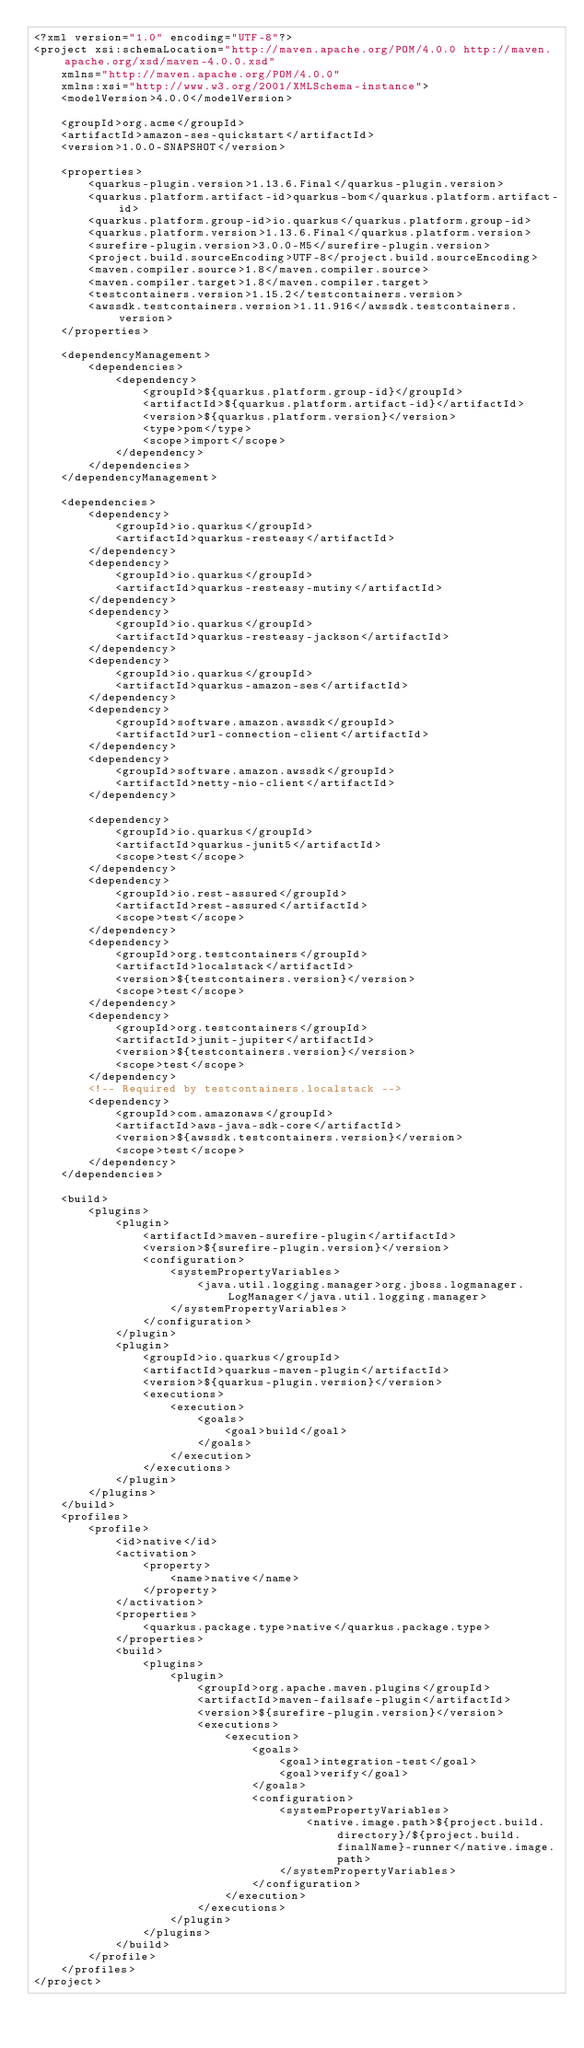Convert code to text. <code><loc_0><loc_0><loc_500><loc_500><_XML_><?xml version="1.0" encoding="UTF-8"?>
<project xsi:schemaLocation="http://maven.apache.org/POM/4.0.0 http://maven.apache.org/xsd/maven-4.0.0.xsd" 
    xmlns="http://maven.apache.org/POM/4.0.0" 
    xmlns:xsi="http://www.w3.org/2001/XMLSchema-instance">
    <modelVersion>4.0.0</modelVersion>

    <groupId>org.acme</groupId>
    <artifactId>amazon-ses-quickstart</artifactId>
    <version>1.0.0-SNAPSHOT</version>

    <properties>
        <quarkus-plugin.version>1.13.6.Final</quarkus-plugin.version>
        <quarkus.platform.artifact-id>quarkus-bom</quarkus.platform.artifact-id>
        <quarkus.platform.group-id>io.quarkus</quarkus.platform.group-id>
        <quarkus.platform.version>1.13.6.Final</quarkus.platform.version>
        <surefire-plugin.version>3.0.0-M5</surefire-plugin.version>
        <project.build.sourceEncoding>UTF-8</project.build.sourceEncoding>
        <maven.compiler.source>1.8</maven.compiler.source>
        <maven.compiler.target>1.8</maven.compiler.target>
        <testcontainers.version>1.15.2</testcontainers.version>
        <awssdk.testcontainers.version>1.11.916</awssdk.testcontainers.version>
    </properties>

    <dependencyManagement>
        <dependencies>
            <dependency>
                <groupId>${quarkus.platform.group-id}</groupId>
                <artifactId>${quarkus.platform.artifact-id}</artifactId>
                <version>${quarkus.platform.version}</version>
                <type>pom</type>
                <scope>import</scope>
            </dependency>
        </dependencies>
    </dependencyManagement>

    <dependencies>
        <dependency>
            <groupId>io.quarkus</groupId>
            <artifactId>quarkus-resteasy</artifactId>
        </dependency>
        <dependency>
            <groupId>io.quarkus</groupId>
            <artifactId>quarkus-resteasy-mutiny</artifactId>
        </dependency>
        <dependency>
            <groupId>io.quarkus</groupId>
            <artifactId>quarkus-resteasy-jackson</artifactId>
        </dependency>
        <dependency>
            <groupId>io.quarkus</groupId>
            <artifactId>quarkus-amazon-ses</artifactId>
        </dependency>
        <dependency>
            <groupId>software.amazon.awssdk</groupId>
            <artifactId>url-connection-client</artifactId>
        </dependency>
        <dependency>
            <groupId>software.amazon.awssdk</groupId>
            <artifactId>netty-nio-client</artifactId>
        </dependency>

        <dependency>
            <groupId>io.quarkus</groupId>
            <artifactId>quarkus-junit5</artifactId>
            <scope>test</scope>
        </dependency>
        <dependency>
            <groupId>io.rest-assured</groupId>
            <artifactId>rest-assured</artifactId>
            <scope>test</scope>
        </dependency>
        <dependency>
            <groupId>org.testcontainers</groupId>
            <artifactId>localstack</artifactId>
            <version>${testcontainers.version}</version>
            <scope>test</scope>
        </dependency>
        <dependency>
            <groupId>org.testcontainers</groupId>
            <artifactId>junit-jupiter</artifactId>
            <version>${testcontainers.version}</version>
            <scope>test</scope>
        </dependency>
        <!-- Required by testcontainers.localstack -->
        <dependency>
            <groupId>com.amazonaws</groupId>
            <artifactId>aws-java-sdk-core</artifactId>
            <version>${awssdk.testcontainers.version}</version>
            <scope>test</scope>
        </dependency>
    </dependencies>

    <build>
        <plugins>
            <plugin>
                <artifactId>maven-surefire-plugin</artifactId>
                <version>${surefire-plugin.version}</version>
                <configuration>
                    <systemPropertyVariables>
                        <java.util.logging.manager>org.jboss.logmanager.LogManager</java.util.logging.manager>
                    </systemPropertyVariables>
                </configuration>
            </plugin>
            <plugin>
                <groupId>io.quarkus</groupId>
                <artifactId>quarkus-maven-plugin</artifactId>
                <version>${quarkus-plugin.version}</version>
                <executions>
                    <execution>
                        <goals>
                            <goal>build</goal>
                        </goals>
                    </execution>
                </executions>
            </plugin>
        </plugins>
    </build>
    <profiles>
        <profile>
            <id>native</id>
            <activation>
                <property>
                    <name>native</name>
                </property>
            </activation>
            <properties>
                <quarkus.package.type>native</quarkus.package.type>
            </properties>
            <build>
                <plugins>
                    <plugin>
                        <groupId>org.apache.maven.plugins</groupId>
                        <artifactId>maven-failsafe-plugin</artifactId>
                        <version>${surefire-plugin.version}</version>
                        <executions>
                            <execution>
                                <goals>
                                    <goal>integration-test</goal>
                                    <goal>verify</goal>
                                </goals>
                                <configuration>
                                    <systemPropertyVariables>
                                        <native.image.path>${project.build.directory}/${project.build.finalName}-runner</native.image.path>
                                    </systemPropertyVariables>
                                </configuration>
                            </execution>
                        </executions>
                    </plugin>
                </plugins>
            </build>
        </profile>
    </profiles>
</project>
</code> 